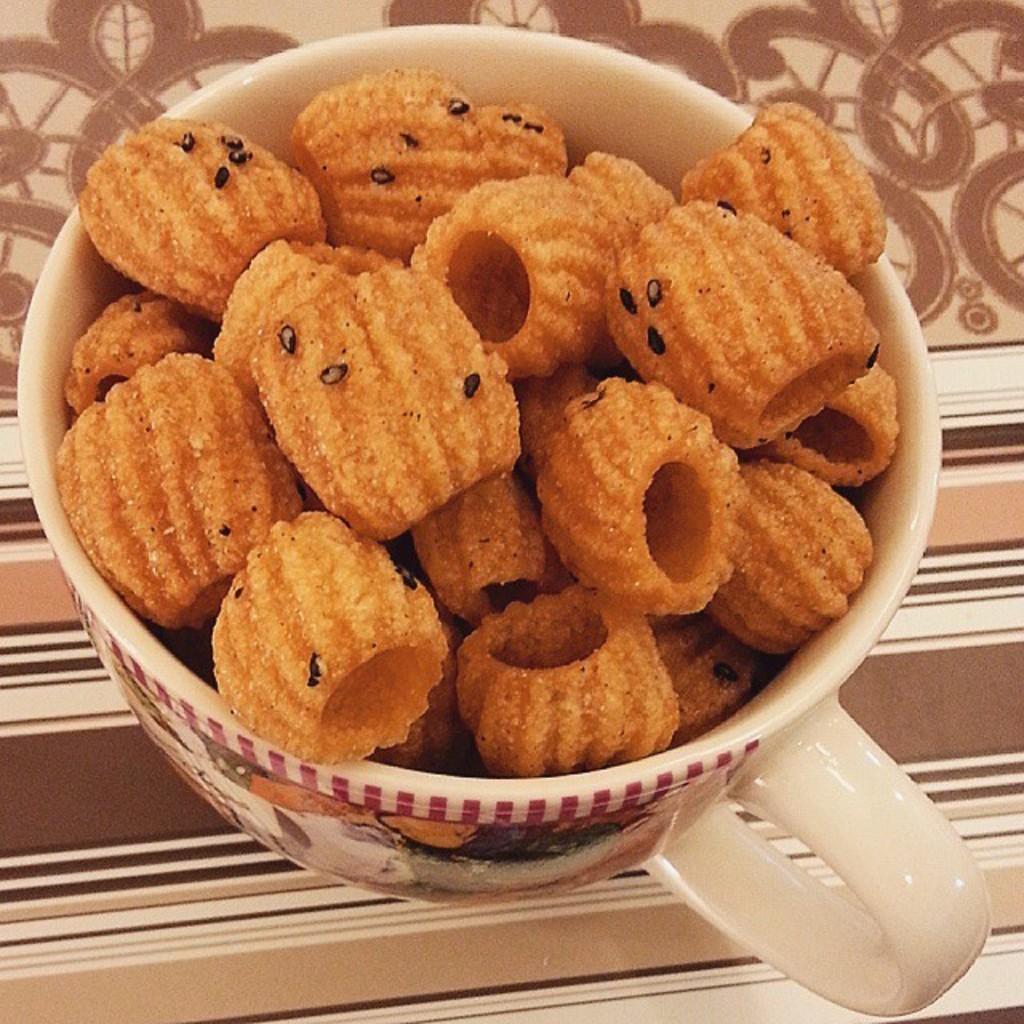What object is visible in the image? There is a cup in the image. Where is the cup located? The cup is on a surface. What is inside the cup? There is food in the cup. What is the cup's tendency to spy on people in the image? The cup does not have a tendency to spy on people, as it is an inanimate object. 